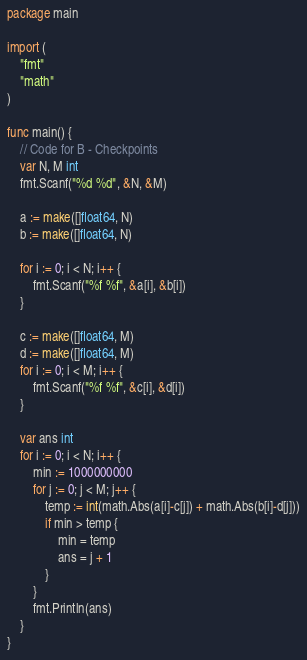<code> <loc_0><loc_0><loc_500><loc_500><_Go_>package main

import (
	"fmt"
	"math"
)

func main() {
	// Code for B - Checkpoints
	var N, M int
	fmt.Scanf("%d %d", &N, &M)

	a := make([]float64, N)
	b := make([]float64, N)

	for i := 0; i < N; i++ {
		fmt.Scanf("%f %f", &a[i], &b[i])
	}

	c := make([]float64, M)
	d := make([]float64, M)
	for i := 0; i < M; i++ {
		fmt.Scanf("%f %f", &c[i], &d[i])
	}

	var ans int
	for i := 0; i < N; i++ {
		min := 1000000000
		for j := 0; j < M; j++ {
			temp := int(math.Abs(a[i]-c[j]) + math.Abs(b[i]-d[j]))
			if min > temp {
				min = temp
				ans = j + 1
			}
		}
		fmt.Println(ans)
	}
}
</code> 